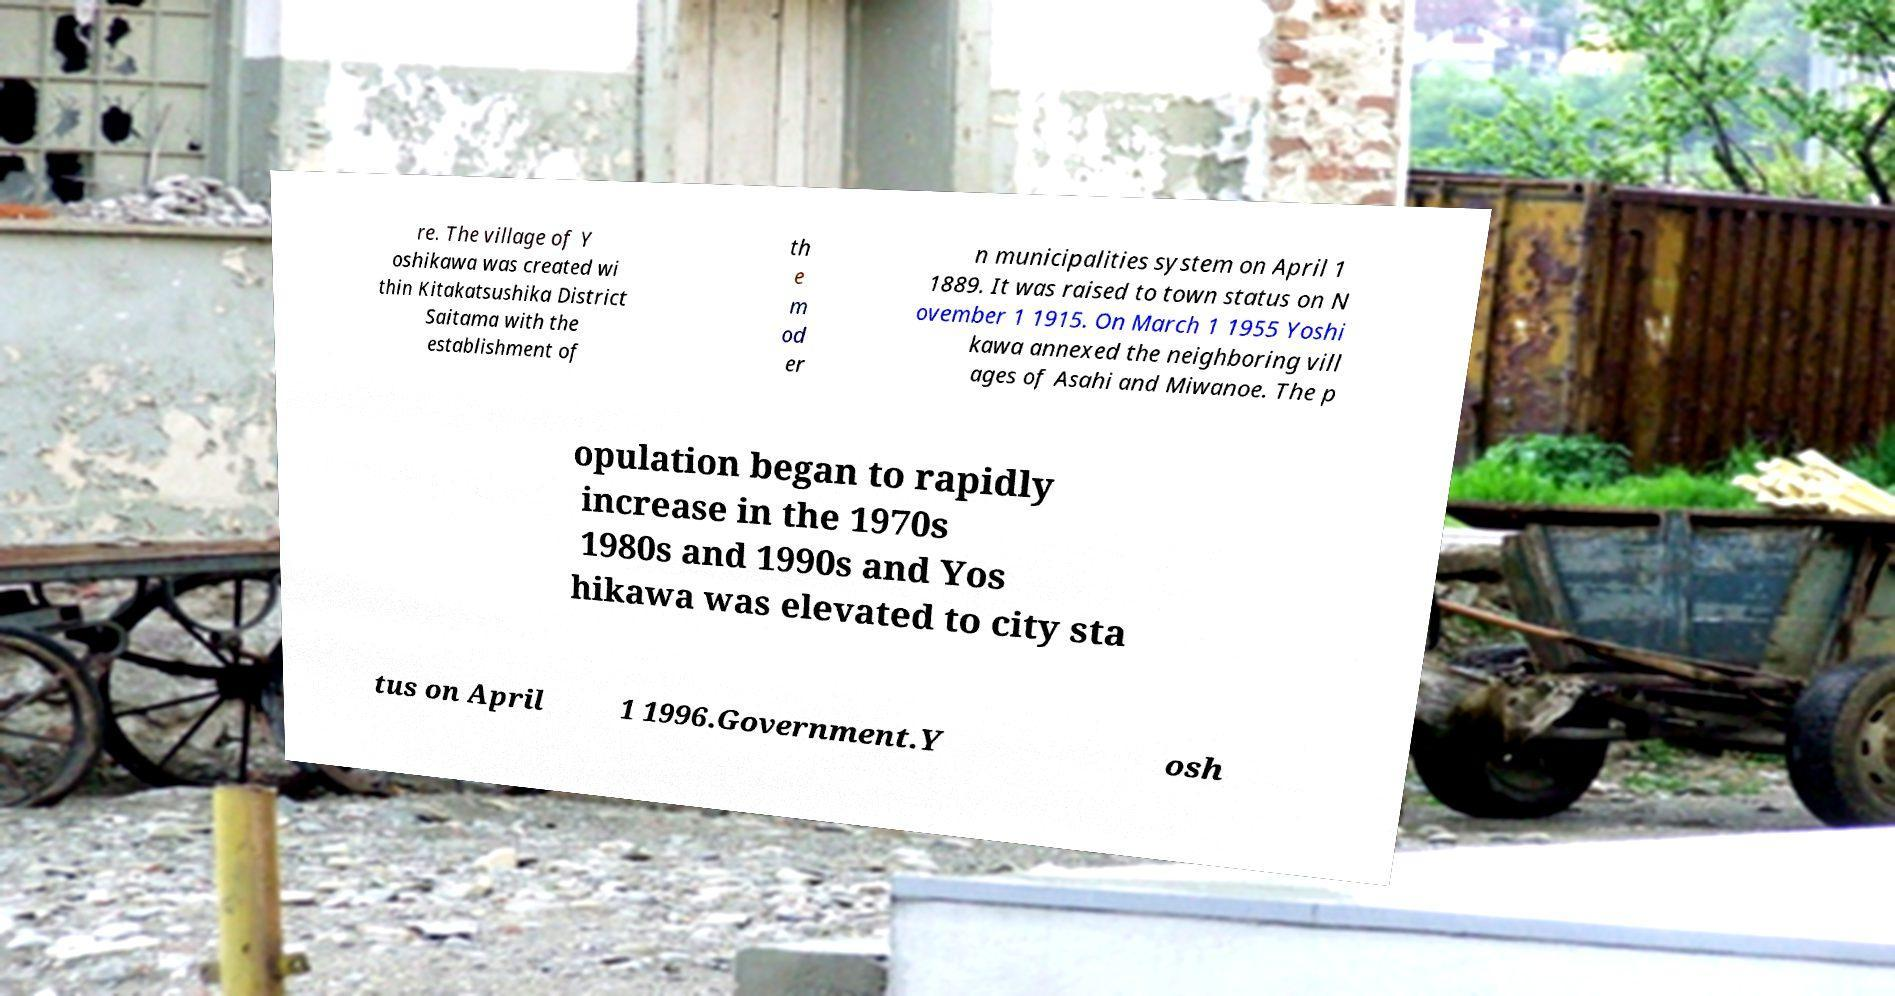Could you assist in decoding the text presented in this image and type it out clearly? re. The village of Y oshikawa was created wi thin Kitakatsushika District Saitama with the establishment of th e m od er n municipalities system on April 1 1889. It was raised to town status on N ovember 1 1915. On March 1 1955 Yoshi kawa annexed the neighboring vill ages of Asahi and Miwanoe. The p opulation began to rapidly increase in the 1970s 1980s and 1990s and Yos hikawa was elevated to city sta tus on April 1 1996.Government.Y osh 